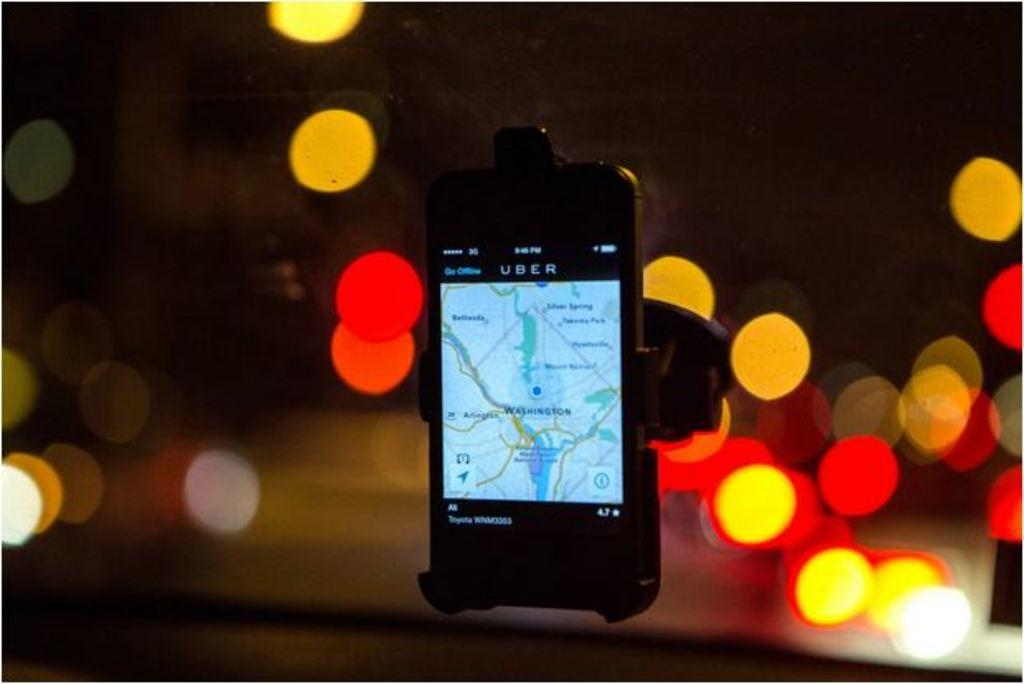<image>
Create a compact narrative representing the image presented. A phone is being used as a navigation system in an Uber. 